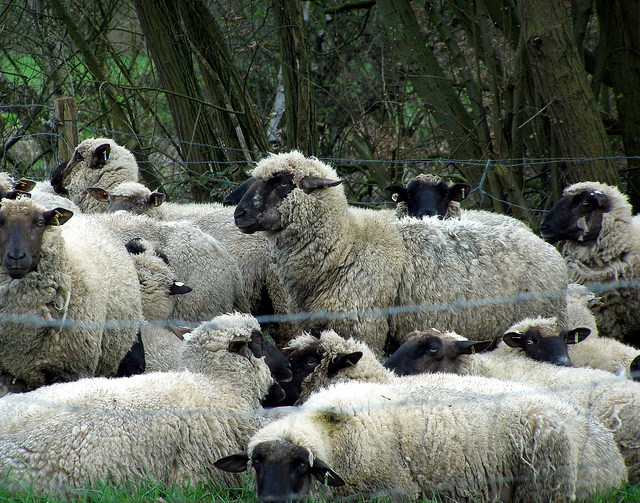What might be the possible reason for the sheep gathering in that location? The sheep appear to be gathered near a fence, likely within a pasture or designated grazing area. Sheep naturally come together in groups for reasons such as warmth, safety from predators, or their innate herding behavior. The fence suggests they might be in a controlled environment, possibly brought together by a farmer or shepherd for feeding, moving to a new grazing location, or protection. 